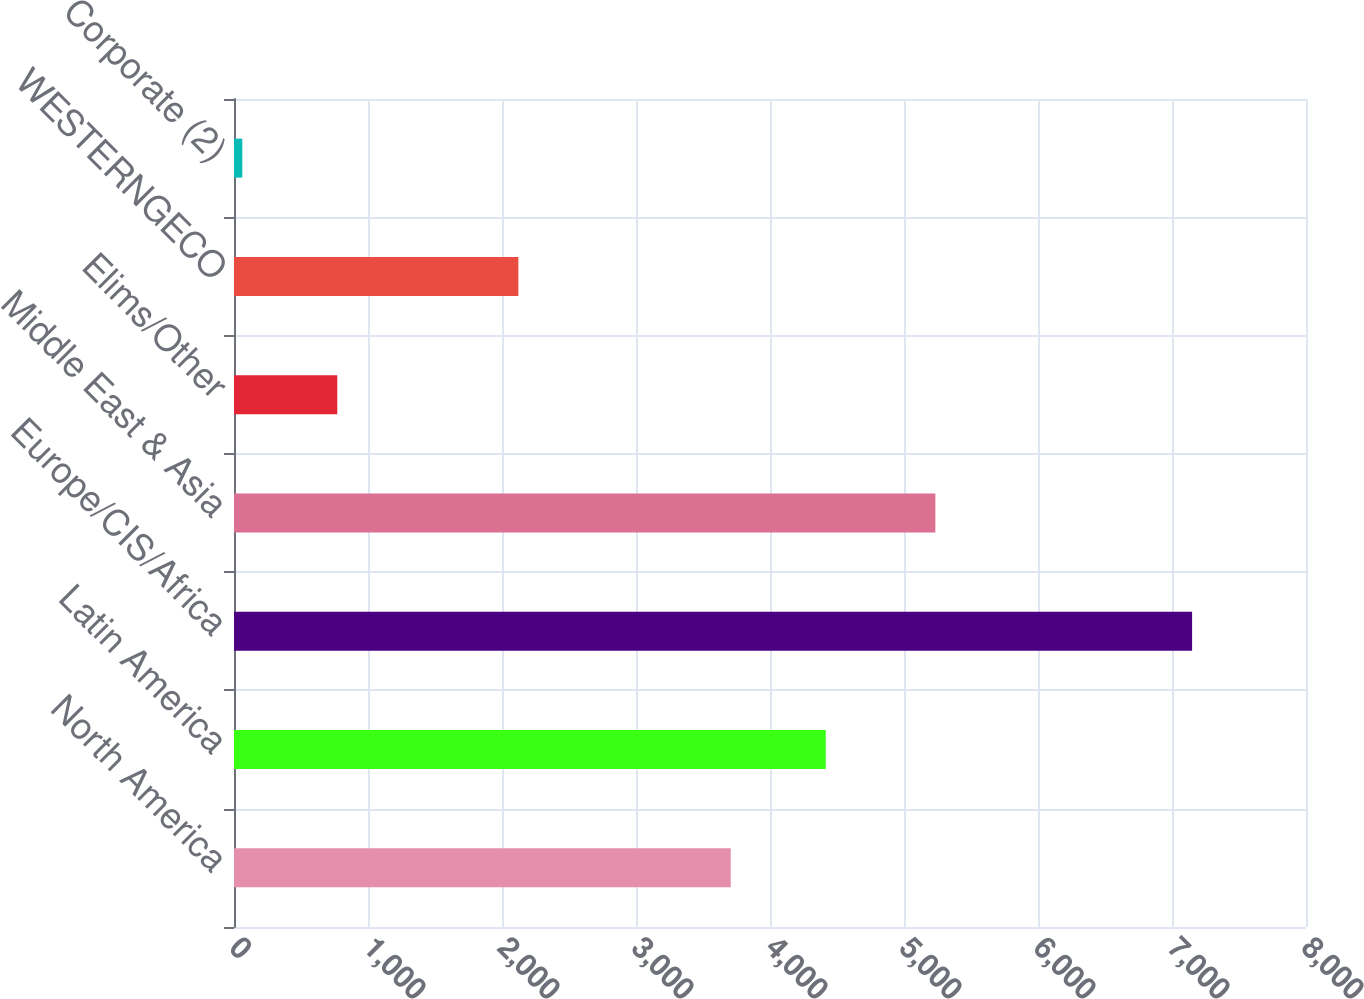Convert chart to OTSL. <chart><loc_0><loc_0><loc_500><loc_500><bar_chart><fcel>North America<fcel>Latin America<fcel>Europe/CIS/Africa<fcel>Middle East & Asia<fcel>Elims/Other<fcel>WESTERNGECO<fcel>Corporate (2)<nl><fcel>3707<fcel>4415.8<fcel>7150<fcel>5234<fcel>770.8<fcel>2122<fcel>62<nl></chart> 